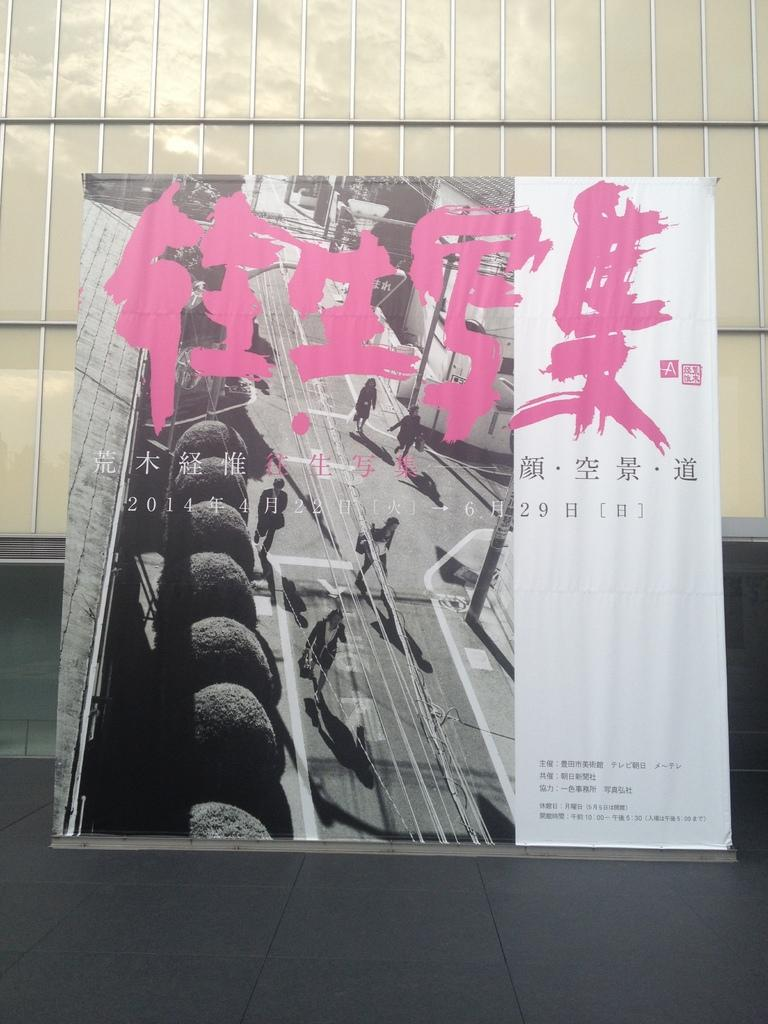What can be seen on the wall in the image? There is a board with a painting on it. What is the subject of the painting? The painting depicts people walking. Is there any additional information or text in the image? Yes, there is some information beside the board. How many apples are on the table in the image? There is no table or apples present in the image. What type of arch can be seen in the image? There is no arch present in the image. 